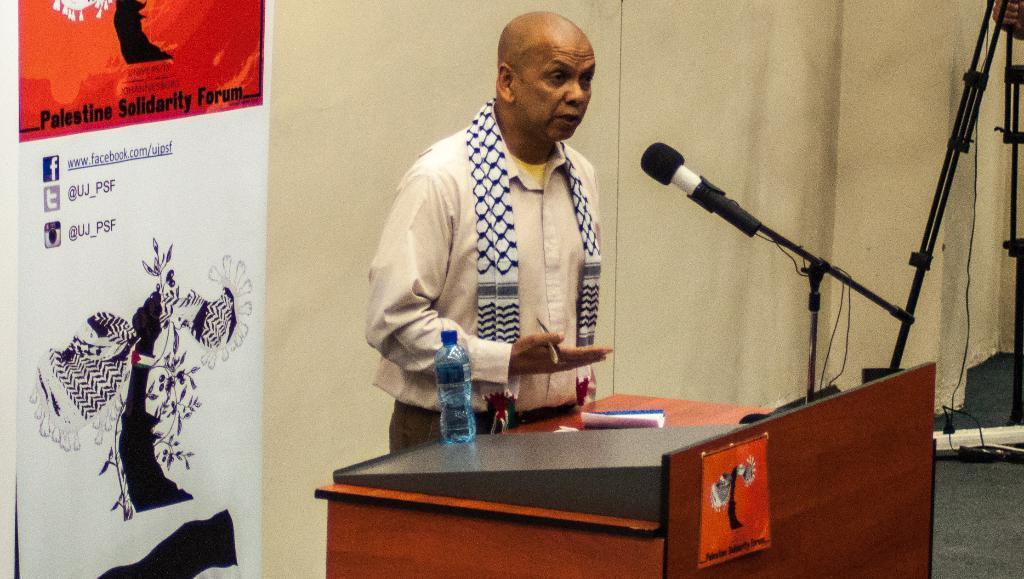Can you describe this image briefly? In the picture there is a bald headed man with scarf in his shoulder stood in front of podium talking on mic,there is a bottle on the podium and on the backside of him there is a poster and to the right side corner there is a tripod stand. 